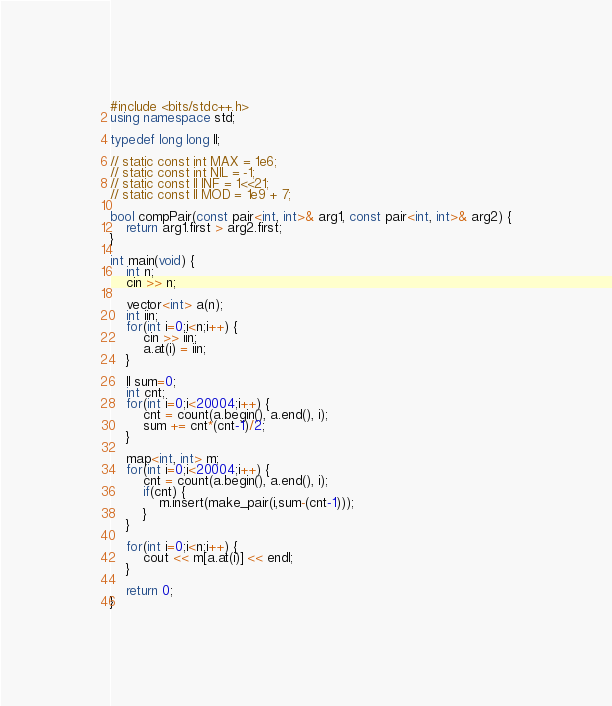<code> <loc_0><loc_0><loc_500><loc_500><_C++_>#include <bits/stdc++.h>
using namespace std;

typedef long long ll;

// static const int MAX = 1e6;
// static const int NIL = -1;
// static const ll INF = 1<<21;
// static const ll MOD = 1e9 + 7;

bool compPair(const pair<int, int>& arg1, const pair<int, int>& arg2) {
    return arg1.first > arg2.first;
}

int main(void) {
    int n;
    cin >> n;

    vector<int> a(n);
    int iin;
    for(int i=0;i<n;i++) {
        cin >> iin;
        a.at(i) = iin;
    }
    
    ll sum=0;
    int cnt;
    for(int i=0;i<20004;i++) {
        cnt = count(a.begin(), a.end(), i);
        sum += cnt*(cnt-1)/2;
    }

    map<int, int> m;
    for(int i=0;i<20004;i++) {
        cnt = count(a.begin(), a.end(), i);
        if(cnt) {
            m.insert(make_pair(i,sum-(cnt-1)));
        }
    }

    for(int i=0;i<n;i++) {
        cout << m[a.at(i)] << endl;
    }

    return 0;
}
</code> 